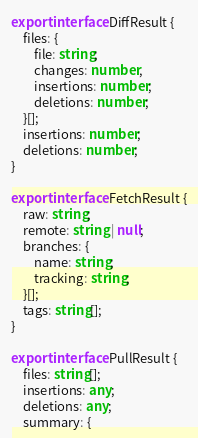<code> <loc_0><loc_0><loc_500><loc_500><_TypeScript_>
export interface DiffResult {
	files: {
		file: string;
		changes: number,
		insertions: number;
		deletions: number;
	}[];
	insertions: number;
	deletions: number;
}

export interface FetchResult {
	raw: string;
	remote: string | null;
	branches: {
		name: string;
		tracking: string;
	}[];
	tags: string[];
}

export interface PullResult {
	files: string[];
	insertions: any;
	deletions: any;
	summary: {</code> 